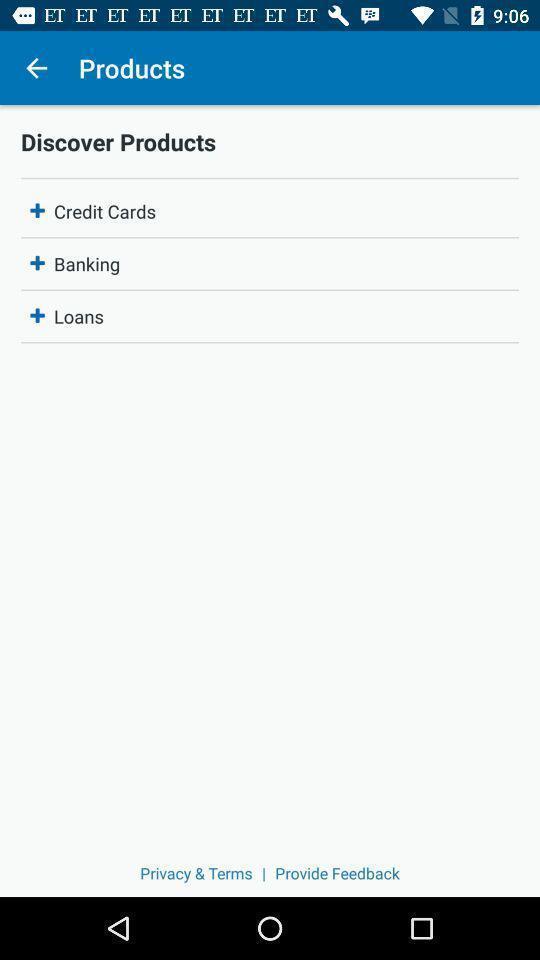Describe this image in words. Window displaying products of an card app. 